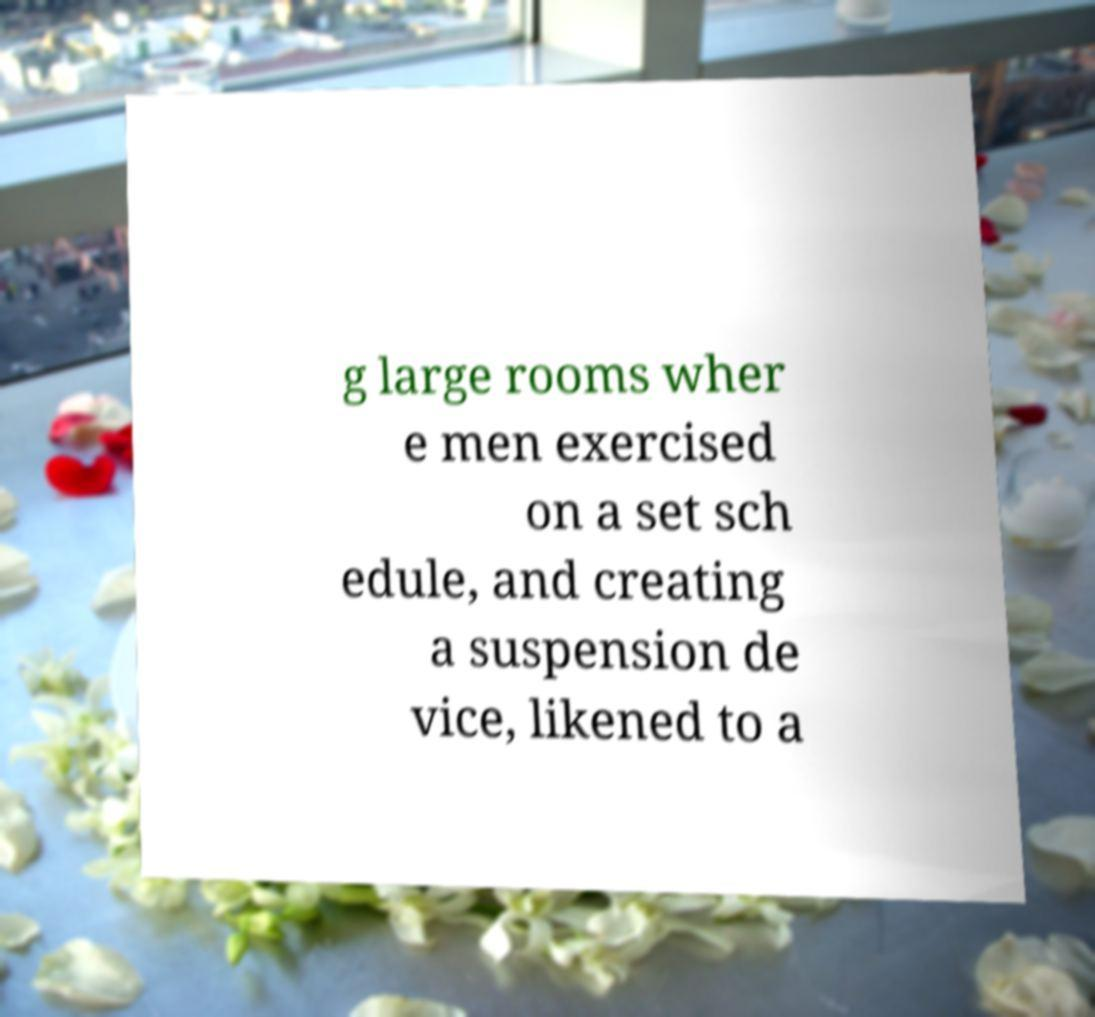What messages or text are displayed in this image? I need them in a readable, typed format. g large rooms wher e men exercised on a set sch edule, and creating a suspension de vice, likened to a 